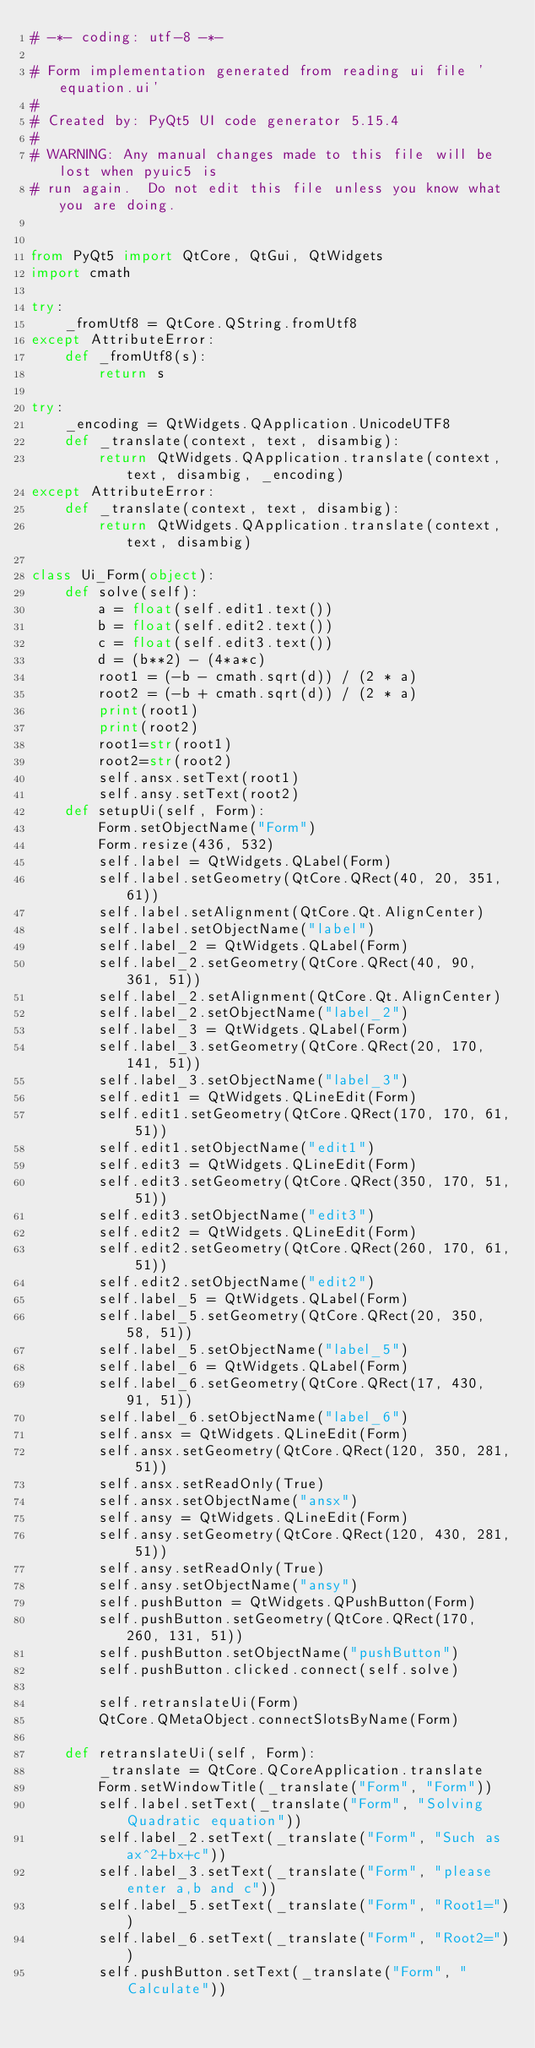Convert code to text. <code><loc_0><loc_0><loc_500><loc_500><_Python_># -*- coding: utf-8 -*-

# Form implementation generated from reading ui file 'equation.ui'
#
# Created by: PyQt5 UI code generator 5.15.4
#
# WARNING: Any manual changes made to this file will be lost when pyuic5 is
# run again.  Do not edit this file unless you know what you are doing.


from PyQt5 import QtCore, QtGui, QtWidgets
import cmath

try:
    _fromUtf8 = QtCore.QString.fromUtf8
except AttributeError:
    def _fromUtf8(s):
        return s

try:
    _encoding = QtWidgets.QApplication.UnicodeUTF8
    def _translate(context, text, disambig):
        return QtWidgets.QApplication.translate(context, text, disambig, _encoding)
except AttributeError:
    def _translate(context, text, disambig):
        return QtWidgets.QApplication.translate(context, text, disambig)

class Ui_Form(object):
    def solve(self):
        a = float(self.edit1.text())
        b = float(self.edit2.text())
        c = float(self.edit3.text())
        d = (b**2) - (4*a*c)
        root1 = (-b - cmath.sqrt(d)) / (2 * a)
        root2 = (-b + cmath.sqrt(d)) / (2 * a)
        print(root1)
        print(root2)
        root1=str(root1)
        root2=str(root2)
        self.ansx.setText(root1)
        self.ansy.setText(root2)
    def setupUi(self, Form):
        Form.setObjectName("Form")
        Form.resize(436, 532)
        self.label = QtWidgets.QLabel(Form)
        self.label.setGeometry(QtCore.QRect(40, 20, 351, 61))
        self.label.setAlignment(QtCore.Qt.AlignCenter)
        self.label.setObjectName("label")
        self.label_2 = QtWidgets.QLabel(Form)
        self.label_2.setGeometry(QtCore.QRect(40, 90, 361, 51))
        self.label_2.setAlignment(QtCore.Qt.AlignCenter)
        self.label_2.setObjectName("label_2")
        self.label_3 = QtWidgets.QLabel(Form)
        self.label_3.setGeometry(QtCore.QRect(20, 170, 141, 51))
        self.label_3.setObjectName("label_3")
        self.edit1 = QtWidgets.QLineEdit(Form)
        self.edit1.setGeometry(QtCore.QRect(170, 170, 61, 51))
        self.edit1.setObjectName("edit1")
        self.edit3 = QtWidgets.QLineEdit(Form)
        self.edit3.setGeometry(QtCore.QRect(350, 170, 51, 51))
        self.edit3.setObjectName("edit3")
        self.edit2 = QtWidgets.QLineEdit(Form)
        self.edit2.setGeometry(QtCore.QRect(260, 170, 61, 51))
        self.edit2.setObjectName("edit2")
        self.label_5 = QtWidgets.QLabel(Form)
        self.label_5.setGeometry(QtCore.QRect(20, 350, 58, 51))
        self.label_5.setObjectName("label_5")
        self.label_6 = QtWidgets.QLabel(Form)
        self.label_6.setGeometry(QtCore.QRect(17, 430, 91, 51))
        self.label_6.setObjectName("label_6")
        self.ansx = QtWidgets.QLineEdit(Form)
        self.ansx.setGeometry(QtCore.QRect(120, 350, 281, 51))
        self.ansx.setReadOnly(True)
        self.ansx.setObjectName("ansx")
        self.ansy = QtWidgets.QLineEdit(Form)
        self.ansy.setGeometry(QtCore.QRect(120, 430, 281, 51))
        self.ansy.setReadOnly(True)
        self.ansy.setObjectName("ansy")
        self.pushButton = QtWidgets.QPushButton(Form)
        self.pushButton.setGeometry(QtCore.QRect(170, 260, 131, 51))
        self.pushButton.setObjectName("pushButton")
        self.pushButton.clicked.connect(self.solve)

        self.retranslateUi(Form)
        QtCore.QMetaObject.connectSlotsByName(Form)

    def retranslateUi(self, Form):
        _translate = QtCore.QCoreApplication.translate
        Form.setWindowTitle(_translate("Form", "Form"))
        self.label.setText(_translate("Form", "Solving Quadratic equation"))
        self.label_2.setText(_translate("Form", "Such as ax^2+bx+c"))
        self.label_3.setText(_translate("Form", "please enter a,b and c"))
        self.label_5.setText(_translate("Form", "Root1="))
        self.label_6.setText(_translate("Form", "Root2="))
        self.pushButton.setText(_translate("Form", "Calculate"))
</code> 